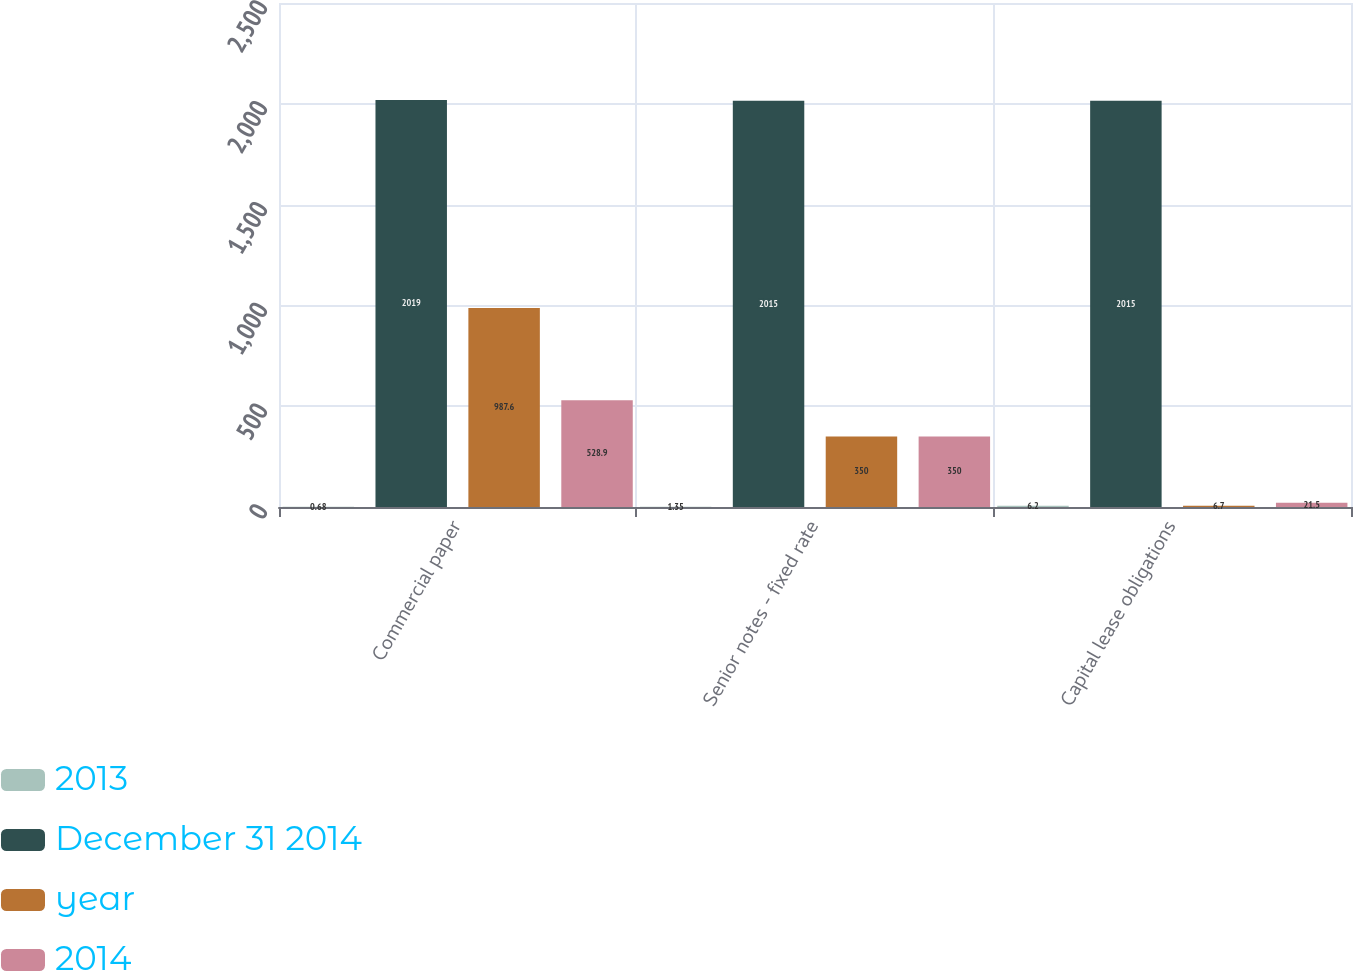Convert chart. <chart><loc_0><loc_0><loc_500><loc_500><stacked_bar_chart><ecel><fcel>Commercial paper<fcel>Senior notes - fixed rate<fcel>Capital lease obligations<nl><fcel>2013<fcel>0.68<fcel>1.35<fcel>6.2<nl><fcel>December 31 2014<fcel>2019<fcel>2015<fcel>2015<nl><fcel>year<fcel>987.6<fcel>350<fcel>6.7<nl><fcel>2014<fcel>528.9<fcel>350<fcel>21.5<nl></chart> 